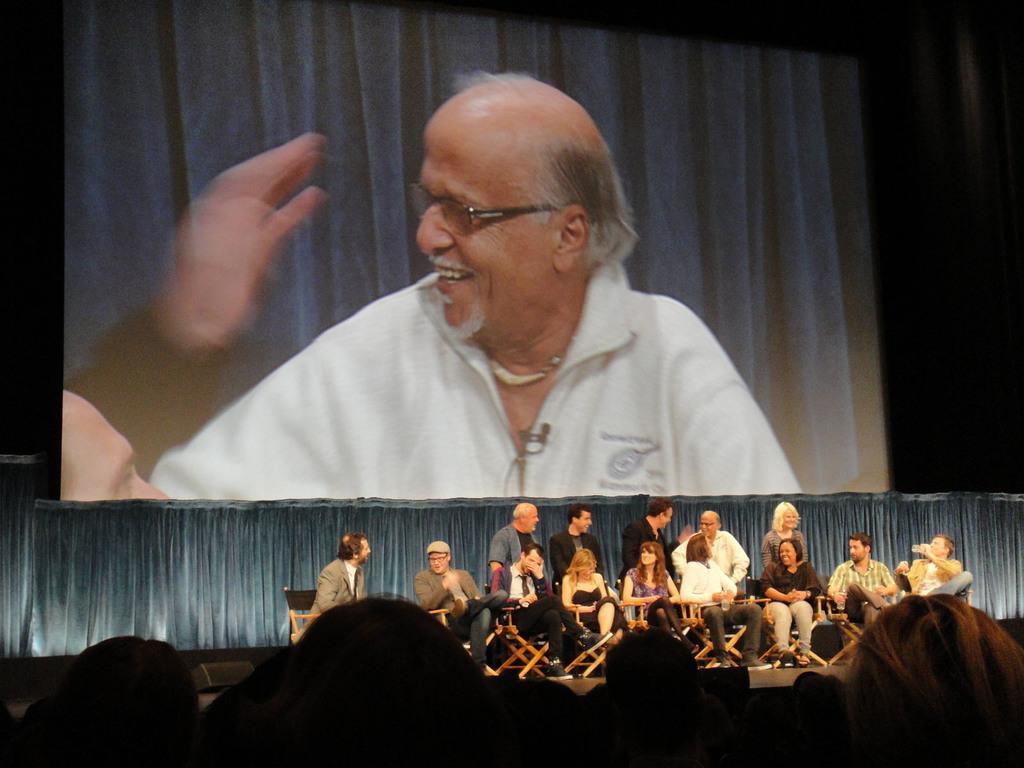Describe this image in one or two sentences. In this image we can see some people and among them few people are sitting and few people are standing on the stage and in the background, we can see the screen with a person picture. 